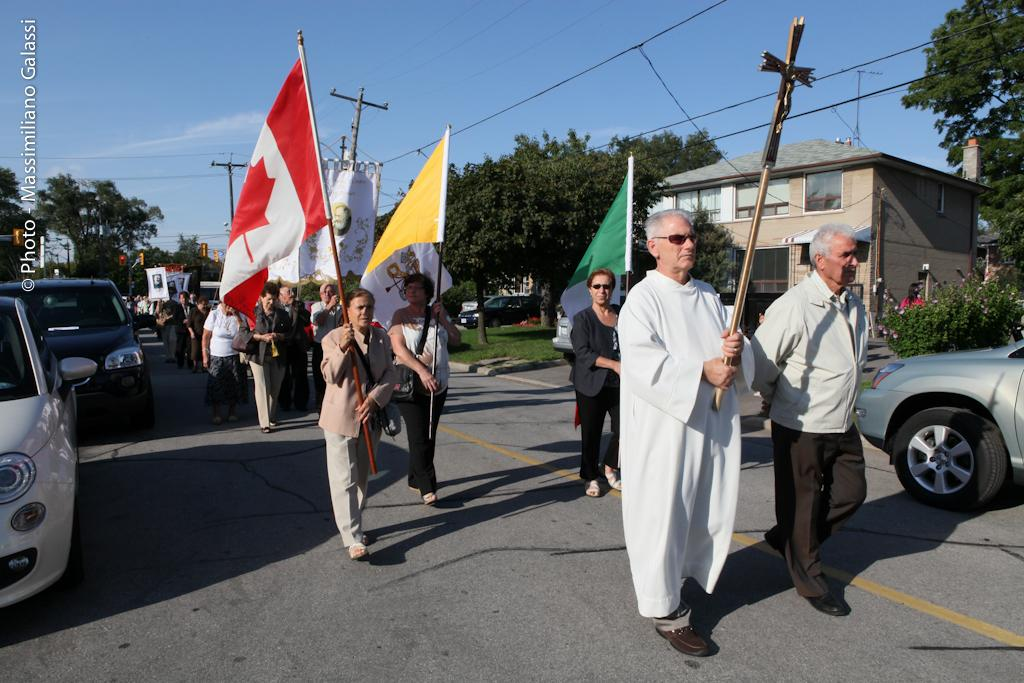How many people are in the image? There is a group of people in the image. What are some people doing in the image? Some people are holding flags. What else can be seen on the road in the image? There are vehicles on the road in the image. What structures are visible in the image? There are buildings visible in the image. What type of natural elements are present in the image? Trees are present in the image. What else can be seen in the image besides people, vehicles, buildings, and trees? Poles are visible in the image. What type of floor can be seen in the image? There is no floor visible in the image; it is an outdoor scene with people, vehicles, buildings, trees, and poles. 